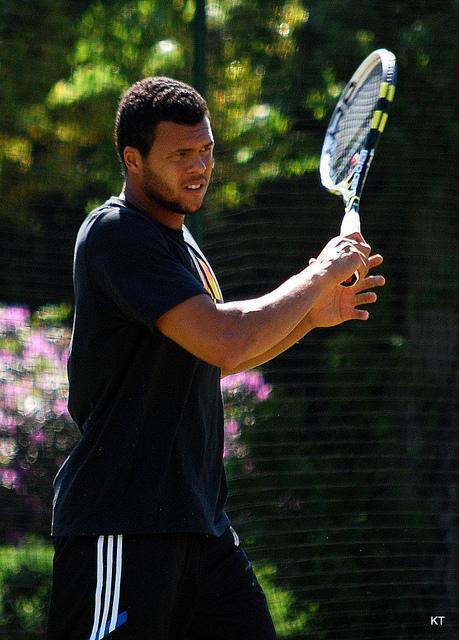How many stripes are on the man's pants?
Give a very brief answer. 3. 